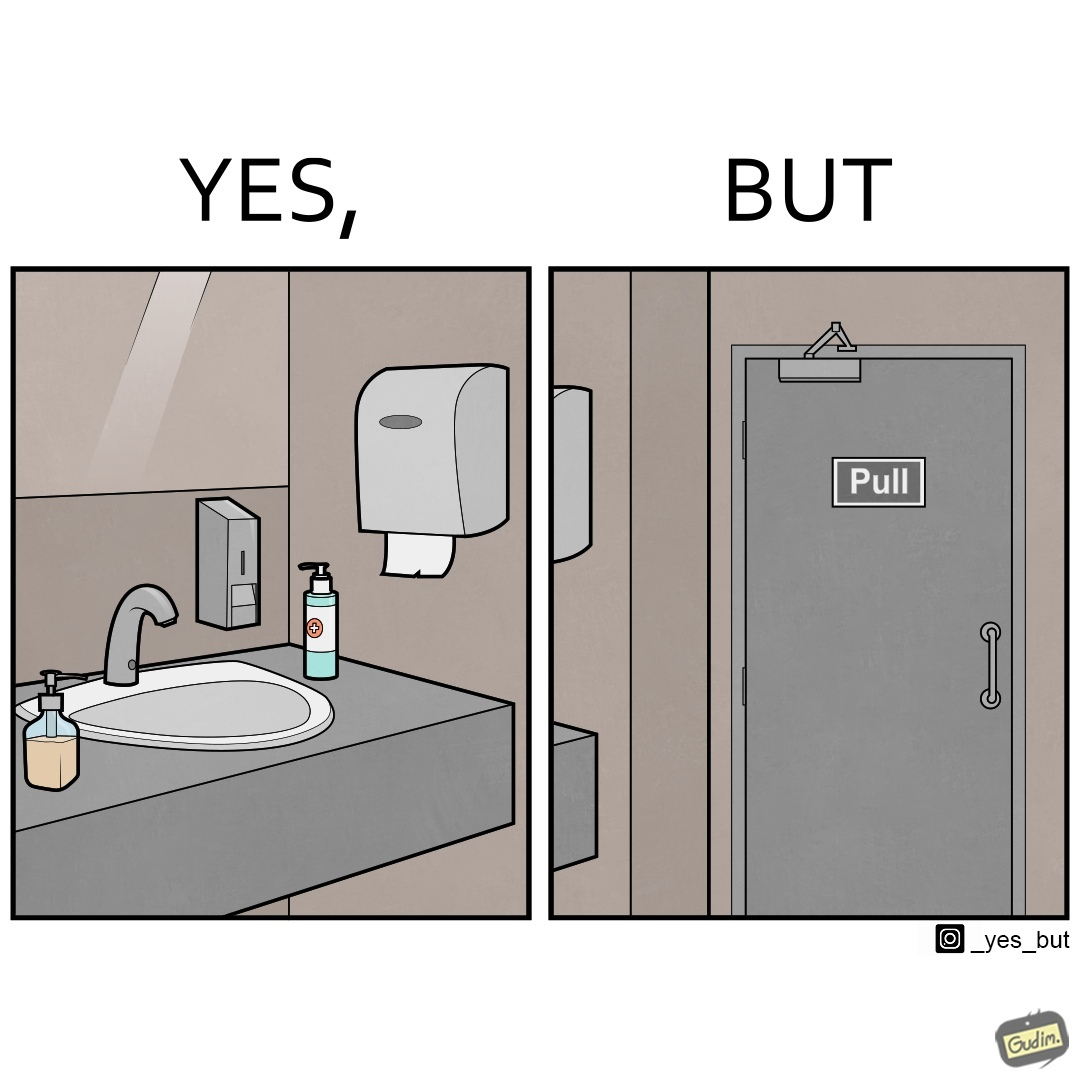Describe the content of this image. The image is ironic, because in the first image in the bathroom there are so many things to clean hands around the basin but in the same bathroom people have to open the doors by hand which can easily spread the germs or bacteria even after times of hand cleaning as there is no way to open it without hands 